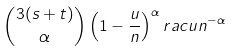<formula> <loc_0><loc_0><loc_500><loc_500>\binom { 3 ( s + t ) } { \alpha } \left ( 1 - \frac { u } { n } \right ) ^ { \alpha } r a c { u } { n } ^ { - \alpha }</formula> 